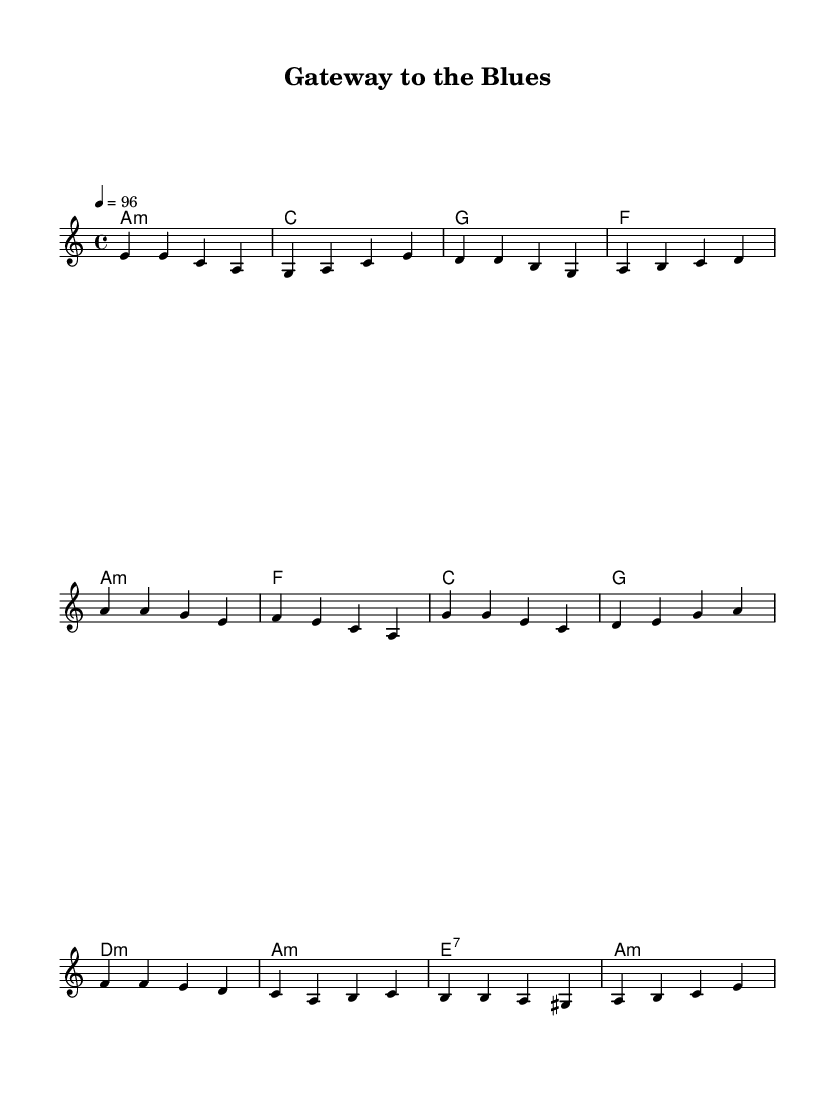What is the key signature of this music? The key signature is A minor, which contains no sharps or flats, indicating the scale's notes derive from A minor.
Answer: A minor What is the time signature of this music? The time signature is 4/4, meaning there are four beats in a measure and a quarter note receives one beat.
Answer: 4/4 What is the tempo marking for this piece? The tempo marking is 4 equals 96, indicating there are 96 quarter note beats per minute, guiding the speed of the performance.
Answer: 96 How many sections are there in the melody? The melody consists of three distinct sections: verse, chorus, and bridge, each contributing to the overall structure of the music.
Answer: Three What is the chord that starts the verse? The verse starts with an A minor chord, setting the tonal foundation for the melody that follows and reflecting the key signature.
Answer: A minor What is the last chord in the harmony section? The last chord in the harmony section is A minor, which reflects both the resolution of the musical phrases and aligns with the piece's key signature.
Answer: A minor What musical genre does this piece belong to? The piece combines elements of reggae and blues, reflecting the fusion of styles evident in both the melody and harmony sections.
Answer: Reggae fusion 